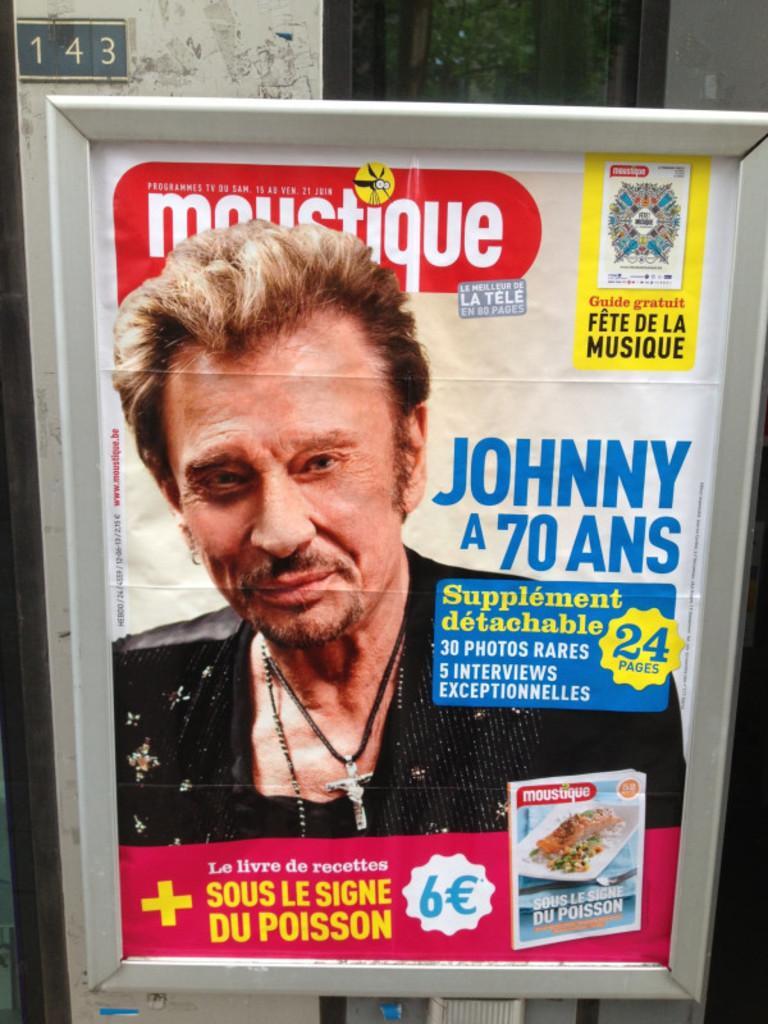How would you summarize this image in a sentence or two? In this picture, we can see a Poster with some text and images on it, and we can see the background with some numbers and the wall. 